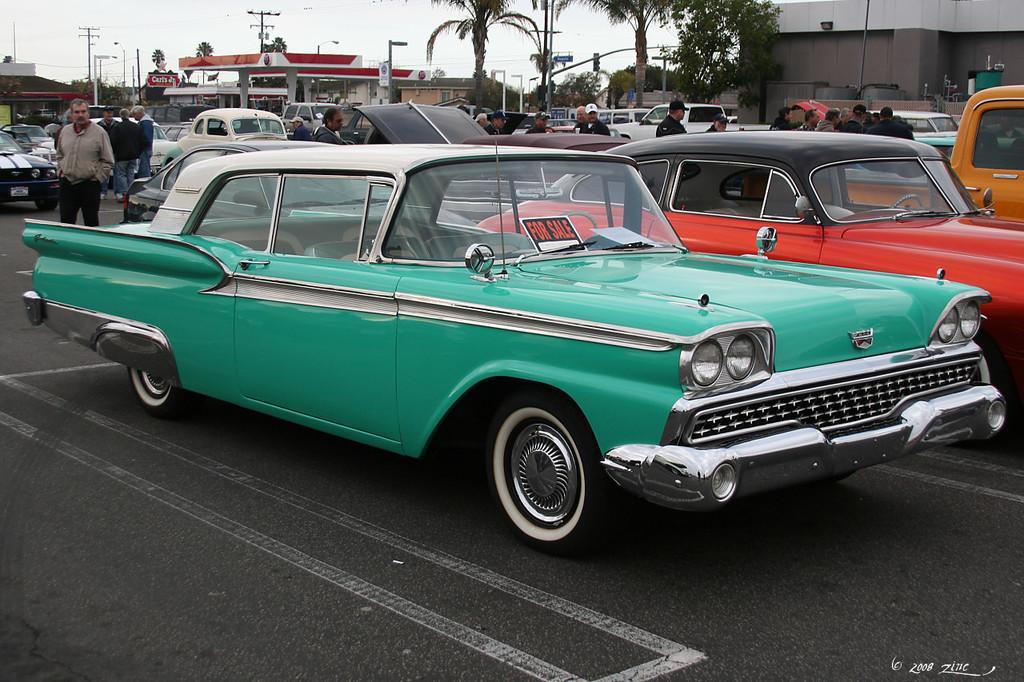In one or two sentences, can you explain what this image depicts? In this picture we can see vehicles and people on the ground and in the background we can see buildings, trees, poles, sky and some objects. 